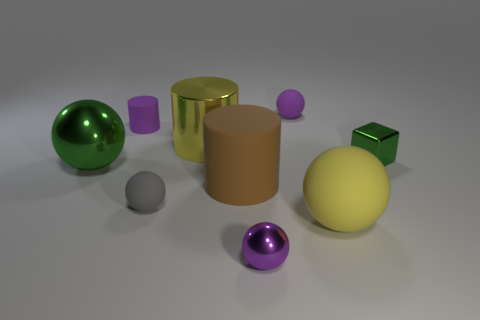Is the shape of the large green metal thing the same as the yellow metal thing?
Your answer should be very brief. No. There is a purple sphere that is the same material as the yellow cylinder; what is its size?
Your response must be concise. Small. Is the number of cylinders less than the number of small objects?
Your answer should be very brief. Yes. What number of big objects are either purple things or yellow rubber balls?
Give a very brief answer. 1. What number of things are in front of the small rubber cylinder and left of the gray thing?
Offer a very short reply. 1. Is the number of small yellow metallic things greater than the number of large yellow metal cylinders?
Provide a succinct answer. No. How many other things are there of the same shape as the large brown object?
Ensure brevity in your answer.  2. Does the small block have the same color as the big shiny ball?
Your answer should be compact. Yes. There is a object that is both to the right of the brown rubber thing and behind the green cube; what material is it?
Give a very brief answer. Rubber. The block is what size?
Keep it short and to the point. Small. 